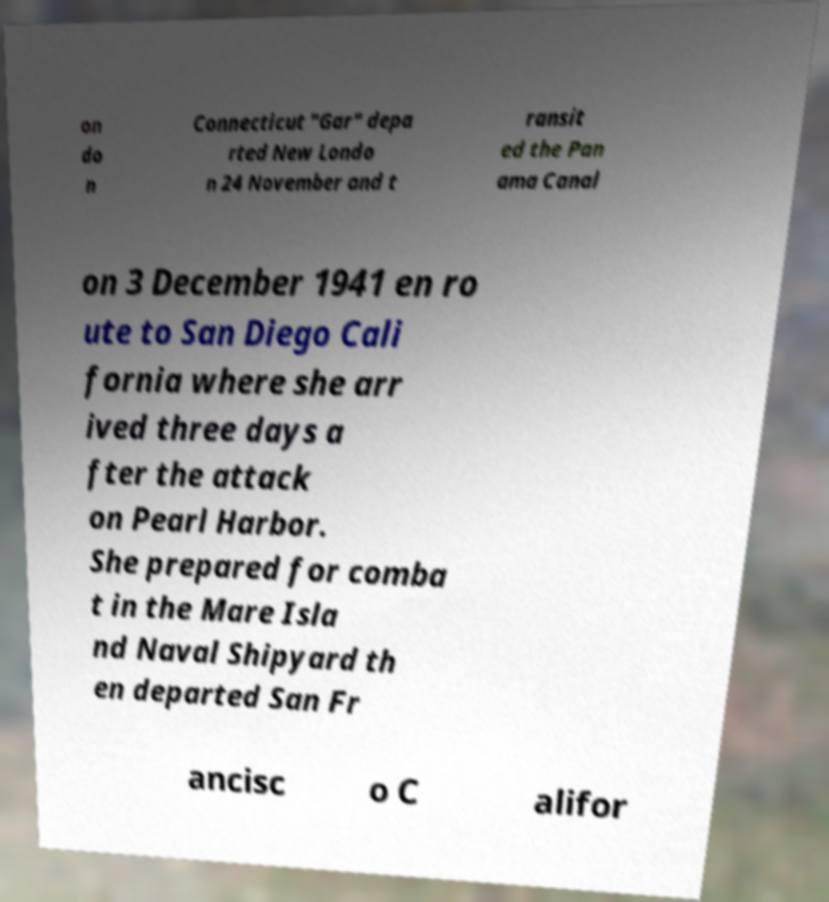For documentation purposes, I need the text within this image transcribed. Could you provide that? on do n Connecticut "Gar" depa rted New Londo n 24 November and t ransit ed the Pan ama Canal on 3 December 1941 en ro ute to San Diego Cali fornia where she arr ived three days a fter the attack on Pearl Harbor. She prepared for comba t in the Mare Isla nd Naval Shipyard th en departed San Fr ancisc o C alifor 